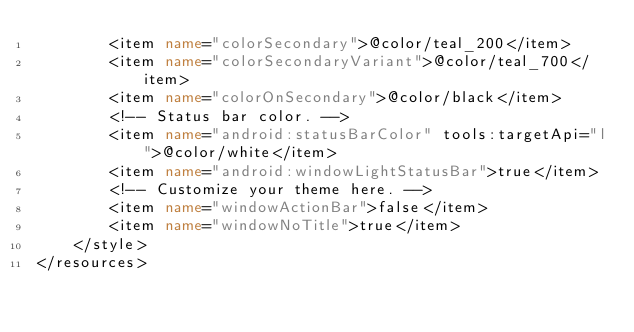<code> <loc_0><loc_0><loc_500><loc_500><_XML_>        <item name="colorSecondary">@color/teal_200</item>
        <item name="colorSecondaryVariant">@color/teal_700</item>
        <item name="colorOnSecondary">@color/black</item>
        <!-- Status bar color. -->
        <item name="android:statusBarColor" tools:targetApi="l">@color/white</item>
        <item name="android:windowLightStatusBar">true</item>
        <!-- Customize your theme here. -->
        <item name="windowActionBar">false</item>
        <item name="windowNoTitle">true</item>
    </style>
</resources></code> 